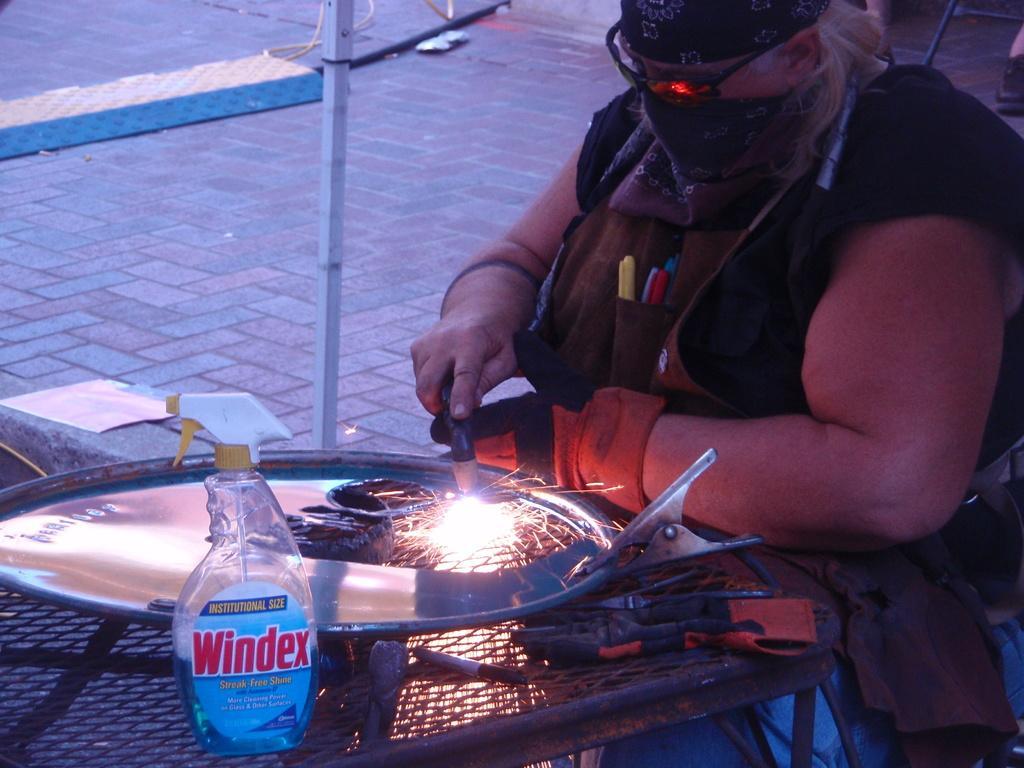Can you describe this image briefly? In this image there is a person sitting and fixing a steel plate and there is a clip, bottle and a steel rod near him. 